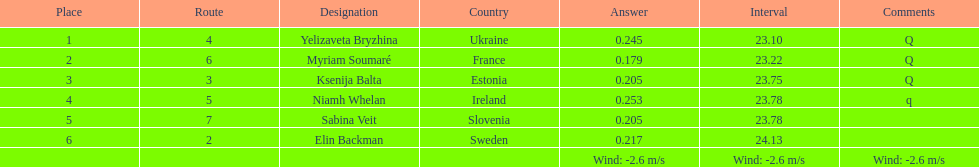The first person to finish in heat 1? Yelizaveta Bryzhina. 